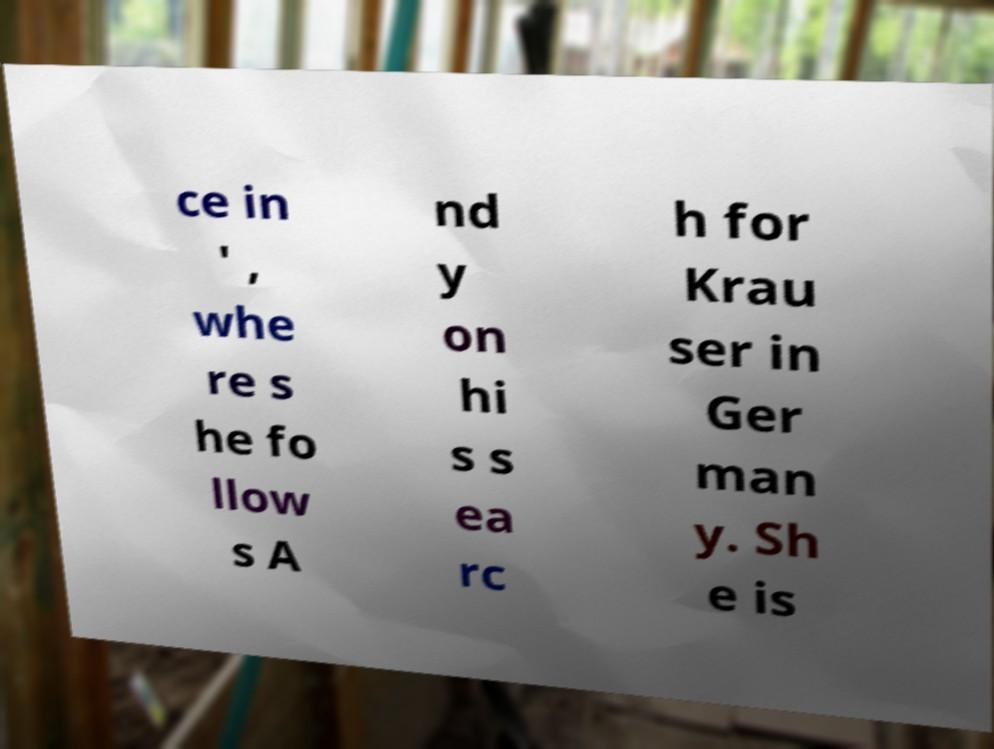Please read and relay the text visible in this image. What does it say? ce in ' , whe re s he fo llow s A nd y on hi s s ea rc h for Krau ser in Ger man y. Sh e is 